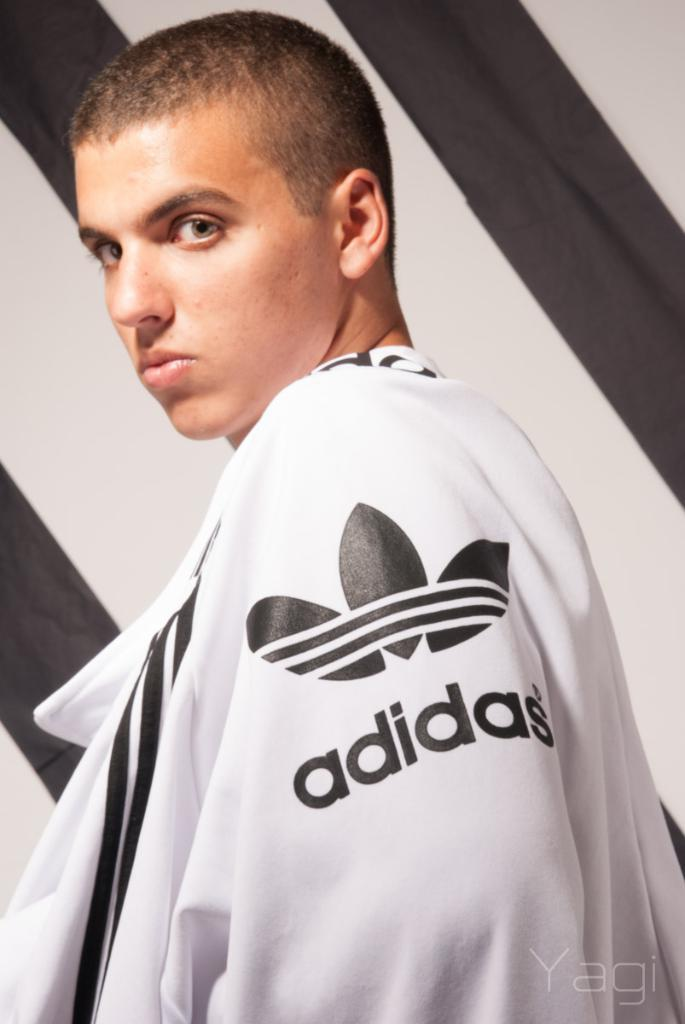<image>
Provide a brief description of the given image. A young man wearing a black and white Adidas hoodie is posing for a photo shoot. 